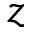<formula> <loc_0><loc_0><loc_500><loc_500>z</formula> 